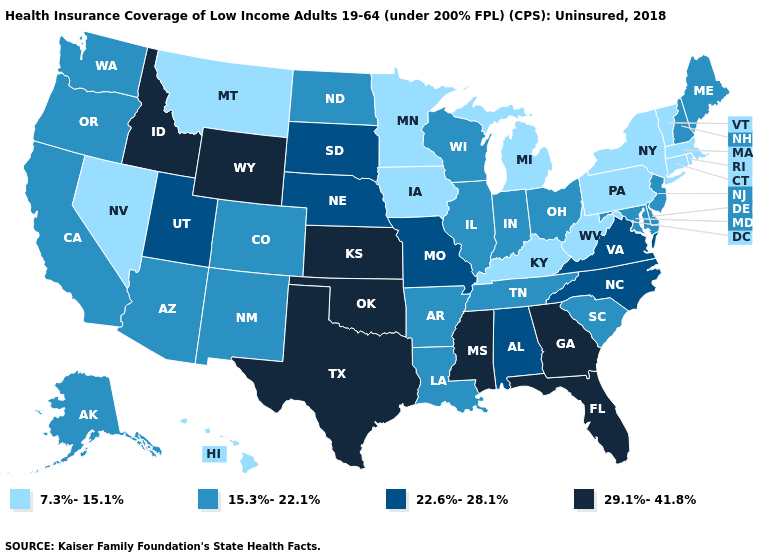Among the states that border Arkansas , which have the lowest value?
Answer briefly. Louisiana, Tennessee. Among the states that border Arkansas , which have the lowest value?
Give a very brief answer. Louisiana, Tennessee. Does the first symbol in the legend represent the smallest category?
Be succinct. Yes. Which states hav the highest value in the MidWest?
Answer briefly. Kansas. Does Nevada have the lowest value in the USA?
Short answer required. Yes. What is the value of Minnesota?
Short answer required. 7.3%-15.1%. Name the states that have a value in the range 7.3%-15.1%?
Write a very short answer. Connecticut, Hawaii, Iowa, Kentucky, Massachusetts, Michigan, Minnesota, Montana, Nevada, New York, Pennsylvania, Rhode Island, Vermont, West Virginia. Does the map have missing data?
Quick response, please. No. Does Virginia have the highest value in the USA?
Short answer required. No. What is the lowest value in the MidWest?
Answer briefly. 7.3%-15.1%. What is the value of Nevada?
Quick response, please. 7.3%-15.1%. Among the states that border South Carolina , which have the lowest value?
Give a very brief answer. North Carolina. Does the map have missing data?
Quick response, please. No. Name the states that have a value in the range 29.1%-41.8%?
Give a very brief answer. Florida, Georgia, Idaho, Kansas, Mississippi, Oklahoma, Texas, Wyoming. 